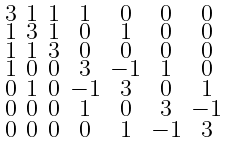Convert formula to latex. <formula><loc_0><loc_0><loc_500><loc_500>\begin{smallmatrix} 3 & 1 & 1 & 1 & 0 & 0 & 0 \\ 1 & 3 & 1 & 0 & 1 & 0 & 0 \\ 1 & 1 & 3 & 0 & 0 & 0 & 0 \\ 1 & 0 & 0 & 3 & - 1 & 1 & 0 \\ 0 & 1 & 0 & - 1 & 3 & 0 & 1 \\ 0 & 0 & 0 & 1 & 0 & 3 & - 1 \\ 0 & 0 & 0 & 0 & 1 & - 1 & 3 \end{smallmatrix}</formula> 